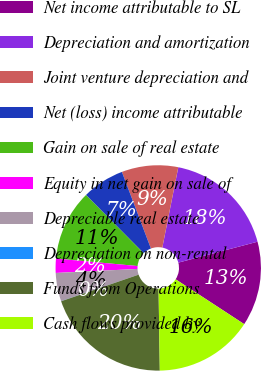<chart> <loc_0><loc_0><loc_500><loc_500><pie_chart><fcel>Net income attributable to SL<fcel>Depreciation and amortization<fcel>Joint venture depreciation and<fcel>Net (loss) income attributable<fcel>Gain on sale of real estate<fcel>Equity in net gain on sale of<fcel>Depreciable real estate<fcel>Depreciation on non-rental<fcel>Funds from Operations<fcel>Cash flows provided by<nl><fcel>13.33%<fcel>17.76%<fcel>8.89%<fcel>6.67%<fcel>11.11%<fcel>2.24%<fcel>4.46%<fcel>0.02%<fcel>19.98%<fcel>15.54%<nl></chart> 